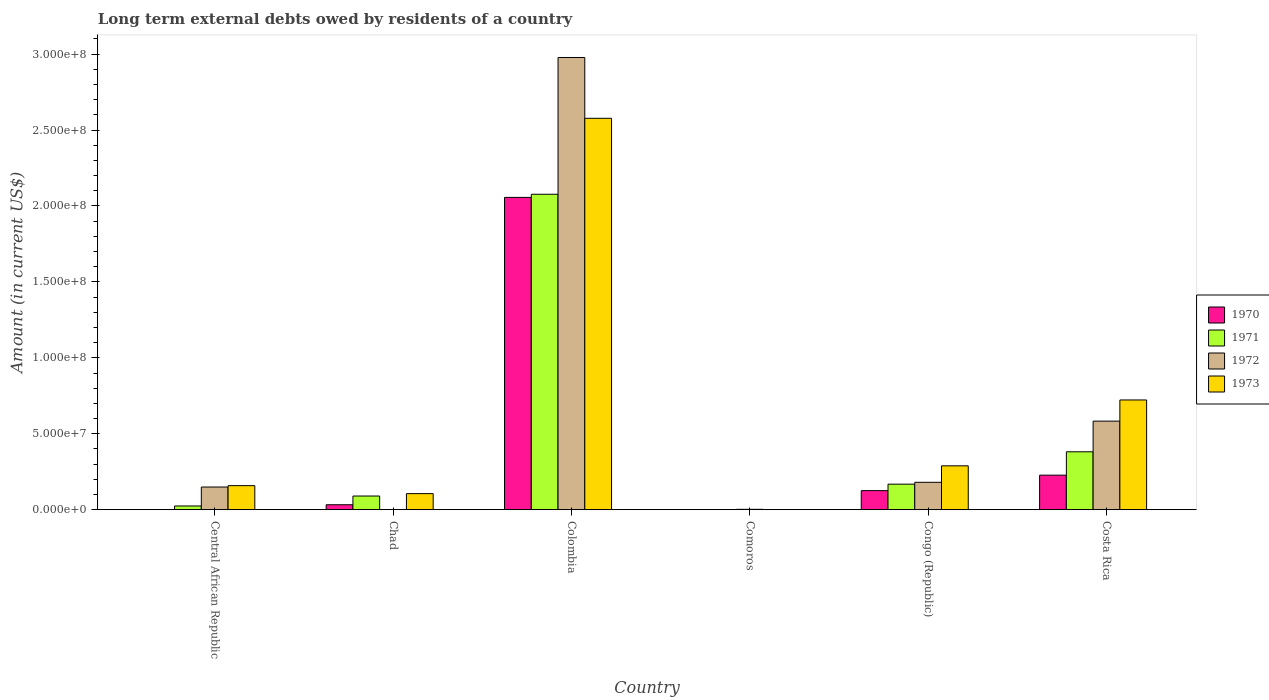Are the number of bars per tick equal to the number of legend labels?
Make the answer very short. No. What is the label of the 4th group of bars from the left?
Offer a very short reply. Comoros. In how many cases, is the number of bars for a given country not equal to the number of legend labels?
Provide a succinct answer. 3. Across all countries, what is the maximum amount of long-term external debts owed by residents in 1972?
Provide a succinct answer. 2.98e+08. Across all countries, what is the minimum amount of long-term external debts owed by residents in 1970?
Make the answer very short. 0. What is the total amount of long-term external debts owed by residents in 1971 in the graph?
Provide a short and direct response. 2.74e+08. What is the difference between the amount of long-term external debts owed by residents in 1973 in Central African Republic and that in Chad?
Your answer should be very brief. 5.26e+06. What is the difference between the amount of long-term external debts owed by residents in 1970 in Costa Rica and the amount of long-term external debts owed by residents in 1973 in Comoros?
Keep it short and to the point. 2.27e+07. What is the average amount of long-term external debts owed by residents in 1971 per country?
Provide a short and direct response. 4.57e+07. What is the difference between the amount of long-term external debts owed by residents of/in 1970 and amount of long-term external debts owed by residents of/in 1973 in Congo (Republic)?
Keep it short and to the point. -1.63e+07. What is the ratio of the amount of long-term external debts owed by residents in 1970 in Chad to that in Congo (Republic)?
Offer a very short reply. 0.26. Is the amount of long-term external debts owed by residents in 1971 in Colombia less than that in Congo (Republic)?
Make the answer very short. No. Is the difference between the amount of long-term external debts owed by residents in 1970 in Colombia and Congo (Republic) greater than the difference between the amount of long-term external debts owed by residents in 1973 in Colombia and Congo (Republic)?
Provide a short and direct response. No. What is the difference between the highest and the second highest amount of long-term external debts owed by residents in 1972?
Ensure brevity in your answer.  2.80e+08. What is the difference between the highest and the lowest amount of long-term external debts owed by residents in 1973?
Your answer should be very brief. 2.58e+08. In how many countries, is the amount of long-term external debts owed by residents in 1970 greater than the average amount of long-term external debts owed by residents in 1970 taken over all countries?
Provide a short and direct response. 1. Is it the case that in every country, the sum of the amount of long-term external debts owed by residents in 1971 and amount of long-term external debts owed by residents in 1970 is greater than the amount of long-term external debts owed by residents in 1973?
Your response must be concise. No. Are all the bars in the graph horizontal?
Provide a succinct answer. No. What is the difference between two consecutive major ticks on the Y-axis?
Offer a terse response. 5.00e+07. Does the graph contain any zero values?
Keep it short and to the point. Yes. Where does the legend appear in the graph?
Your response must be concise. Center right. How many legend labels are there?
Make the answer very short. 4. How are the legend labels stacked?
Offer a terse response. Vertical. What is the title of the graph?
Offer a very short reply. Long term external debts owed by residents of a country. Does "1995" appear as one of the legend labels in the graph?
Offer a terse response. No. What is the label or title of the X-axis?
Provide a succinct answer. Country. What is the Amount (in current US$) in 1971 in Central African Republic?
Keep it short and to the point. 2.45e+06. What is the Amount (in current US$) of 1972 in Central African Republic?
Keep it short and to the point. 1.49e+07. What is the Amount (in current US$) in 1973 in Central African Republic?
Keep it short and to the point. 1.58e+07. What is the Amount (in current US$) of 1970 in Chad?
Offer a terse response. 3.26e+06. What is the Amount (in current US$) of 1971 in Chad?
Provide a short and direct response. 9.01e+06. What is the Amount (in current US$) in 1973 in Chad?
Your answer should be compact. 1.06e+07. What is the Amount (in current US$) of 1970 in Colombia?
Your answer should be compact. 2.06e+08. What is the Amount (in current US$) of 1971 in Colombia?
Your answer should be very brief. 2.08e+08. What is the Amount (in current US$) in 1972 in Colombia?
Keep it short and to the point. 2.98e+08. What is the Amount (in current US$) of 1973 in Colombia?
Ensure brevity in your answer.  2.58e+08. What is the Amount (in current US$) of 1971 in Comoros?
Your response must be concise. 0. What is the Amount (in current US$) of 1972 in Comoros?
Your answer should be compact. 2.48e+05. What is the Amount (in current US$) of 1973 in Comoros?
Provide a short and direct response. 5.40e+04. What is the Amount (in current US$) in 1970 in Congo (Republic)?
Provide a succinct answer. 1.26e+07. What is the Amount (in current US$) in 1971 in Congo (Republic)?
Provide a short and direct response. 1.68e+07. What is the Amount (in current US$) in 1972 in Congo (Republic)?
Give a very brief answer. 1.80e+07. What is the Amount (in current US$) in 1973 in Congo (Republic)?
Your response must be concise. 2.89e+07. What is the Amount (in current US$) in 1970 in Costa Rica?
Make the answer very short. 2.27e+07. What is the Amount (in current US$) of 1971 in Costa Rica?
Ensure brevity in your answer.  3.81e+07. What is the Amount (in current US$) of 1972 in Costa Rica?
Give a very brief answer. 5.83e+07. What is the Amount (in current US$) in 1973 in Costa Rica?
Ensure brevity in your answer.  7.23e+07. Across all countries, what is the maximum Amount (in current US$) of 1970?
Your answer should be very brief. 2.06e+08. Across all countries, what is the maximum Amount (in current US$) of 1971?
Offer a very short reply. 2.08e+08. Across all countries, what is the maximum Amount (in current US$) in 1972?
Your answer should be very brief. 2.98e+08. Across all countries, what is the maximum Amount (in current US$) in 1973?
Offer a very short reply. 2.58e+08. Across all countries, what is the minimum Amount (in current US$) in 1971?
Provide a succinct answer. 0. Across all countries, what is the minimum Amount (in current US$) of 1973?
Make the answer very short. 5.40e+04. What is the total Amount (in current US$) in 1970 in the graph?
Ensure brevity in your answer.  2.44e+08. What is the total Amount (in current US$) in 1971 in the graph?
Your response must be concise. 2.74e+08. What is the total Amount (in current US$) of 1972 in the graph?
Ensure brevity in your answer.  3.89e+08. What is the total Amount (in current US$) of 1973 in the graph?
Keep it short and to the point. 3.85e+08. What is the difference between the Amount (in current US$) of 1971 in Central African Republic and that in Chad?
Make the answer very short. -6.56e+06. What is the difference between the Amount (in current US$) of 1973 in Central African Republic and that in Chad?
Keep it short and to the point. 5.26e+06. What is the difference between the Amount (in current US$) in 1971 in Central African Republic and that in Colombia?
Make the answer very short. -2.05e+08. What is the difference between the Amount (in current US$) of 1972 in Central African Republic and that in Colombia?
Offer a terse response. -2.83e+08. What is the difference between the Amount (in current US$) of 1973 in Central African Republic and that in Colombia?
Provide a short and direct response. -2.42e+08. What is the difference between the Amount (in current US$) of 1972 in Central African Republic and that in Comoros?
Provide a succinct answer. 1.47e+07. What is the difference between the Amount (in current US$) in 1973 in Central African Republic and that in Comoros?
Give a very brief answer. 1.58e+07. What is the difference between the Amount (in current US$) in 1971 in Central African Republic and that in Congo (Republic)?
Make the answer very short. -1.44e+07. What is the difference between the Amount (in current US$) in 1972 in Central African Republic and that in Congo (Republic)?
Offer a very short reply. -3.10e+06. What is the difference between the Amount (in current US$) in 1973 in Central African Republic and that in Congo (Republic)?
Provide a succinct answer. -1.30e+07. What is the difference between the Amount (in current US$) of 1971 in Central African Republic and that in Costa Rica?
Provide a short and direct response. -3.57e+07. What is the difference between the Amount (in current US$) of 1972 in Central African Republic and that in Costa Rica?
Ensure brevity in your answer.  -4.34e+07. What is the difference between the Amount (in current US$) in 1973 in Central African Republic and that in Costa Rica?
Your response must be concise. -5.64e+07. What is the difference between the Amount (in current US$) in 1970 in Chad and that in Colombia?
Make the answer very short. -2.02e+08. What is the difference between the Amount (in current US$) in 1971 in Chad and that in Colombia?
Provide a succinct answer. -1.99e+08. What is the difference between the Amount (in current US$) in 1973 in Chad and that in Colombia?
Provide a short and direct response. -2.47e+08. What is the difference between the Amount (in current US$) of 1973 in Chad and that in Comoros?
Ensure brevity in your answer.  1.05e+07. What is the difference between the Amount (in current US$) in 1970 in Chad and that in Congo (Republic)?
Keep it short and to the point. -9.29e+06. What is the difference between the Amount (in current US$) of 1971 in Chad and that in Congo (Republic)?
Provide a succinct answer. -7.80e+06. What is the difference between the Amount (in current US$) in 1973 in Chad and that in Congo (Republic)?
Give a very brief answer. -1.83e+07. What is the difference between the Amount (in current US$) in 1970 in Chad and that in Costa Rica?
Provide a short and direct response. -1.95e+07. What is the difference between the Amount (in current US$) in 1971 in Chad and that in Costa Rica?
Your answer should be very brief. -2.91e+07. What is the difference between the Amount (in current US$) of 1973 in Chad and that in Costa Rica?
Provide a succinct answer. -6.17e+07. What is the difference between the Amount (in current US$) of 1972 in Colombia and that in Comoros?
Ensure brevity in your answer.  2.98e+08. What is the difference between the Amount (in current US$) in 1973 in Colombia and that in Comoros?
Your answer should be very brief. 2.58e+08. What is the difference between the Amount (in current US$) of 1970 in Colombia and that in Congo (Republic)?
Make the answer very short. 1.93e+08. What is the difference between the Amount (in current US$) in 1971 in Colombia and that in Congo (Republic)?
Keep it short and to the point. 1.91e+08. What is the difference between the Amount (in current US$) in 1972 in Colombia and that in Congo (Republic)?
Your answer should be compact. 2.80e+08. What is the difference between the Amount (in current US$) of 1973 in Colombia and that in Congo (Republic)?
Offer a terse response. 2.29e+08. What is the difference between the Amount (in current US$) of 1970 in Colombia and that in Costa Rica?
Provide a succinct answer. 1.83e+08. What is the difference between the Amount (in current US$) of 1971 in Colombia and that in Costa Rica?
Provide a succinct answer. 1.70e+08. What is the difference between the Amount (in current US$) of 1972 in Colombia and that in Costa Rica?
Provide a short and direct response. 2.39e+08. What is the difference between the Amount (in current US$) in 1973 in Colombia and that in Costa Rica?
Your answer should be compact. 1.85e+08. What is the difference between the Amount (in current US$) in 1972 in Comoros and that in Congo (Republic)?
Offer a very short reply. -1.78e+07. What is the difference between the Amount (in current US$) of 1973 in Comoros and that in Congo (Republic)?
Offer a terse response. -2.88e+07. What is the difference between the Amount (in current US$) in 1972 in Comoros and that in Costa Rica?
Provide a short and direct response. -5.81e+07. What is the difference between the Amount (in current US$) in 1973 in Comoros and that in Costa Rica?
Make the answer very short. -7.22e+07. What is the difference between the Amount (in current US$) of 1970 in Congo (Republic) and that in Costa Rica?
Give a very brief answer. -1.02e+07. What is the difference between the Amount (in current US$) in 1971 in Congo (Republic) and that in Costa Rica?
Ensure brevity in your answer.  -2.13e+07. What is the difference between the Amount (in current US$) in 1972 in Congo (Republic) and that in Costa Rica?
Your answer should be very brief. -4.03e+07. What is the difference between the Amount (in current US$) of 1973 in Congo (Republic) and that in Costa Rica?
Your response must be concise. -4.34e+07. What is the difference between the Amount (in current US$) in 1971 in Central African Republic and the Amount (in current US$) in 1973 in Chad?
Your answer should be compact. -8.13e+06. What is the difference between the Amount (in current US$) of 1972 in Central African Republic and the Amount (in current US$) of 1973 in Chad?
Offer a very short reply. 4.35e+06. What is the difference between the Amount (in current US$) of 1971 in Central African Republic and the Amount (in current US$) of 1972 in Colombia?
Give a very brief answer. -2.95e+08. What is the difference between the Amount (in current US$) of 1971 in Central African Republic and the Amount (in current US$) of 1973 in Colombia?
Give a very brief answer. -2.55e+08. What is the difference between the Amount (in current US$) in 1972 in Central African Republic and the Amount (in current US$) in 1973 in Colombia?
Give a very brief answer. -2.43e+08. What is the difference between the Amount (in current US$) of 1971 in Central African Republic and the Amount (in current US$) of 1972 in Comoros?
Make the answer very short. 2.20e+06. What is the difference between the Amount (in current US$) of 1971 in Central African Republic and the Amount (in current US$) of 1973 in Comoros?
Provide a short and direct response. 2.40e+06. What is the difference between the Amount (in current US$) in 1972 in Central African Republic and the Amount (in current US$) in 1973 in Comoros?
Ensure brevity in your answer.  1.49e+07. What is the difference between the Amount (in current US$) in 1971 in Central African Republic and the Amount (in current US$) in 1972 in Congo (Republic)?
Make the answer very short. -1.56e+07. What is the difference between the Amount (in current US$) of 1971 in Central African Republic and the Amount (in current US$) of 1973 in Congo (Republic)?
Provide a short and direct response. -2.64e+07. What is the difference between the Amount (in current US$) of 1972 in Central African Republic and the Amount (in current US$) of 1973 in Congo (Republic)?
Provide a short and direct response. -1.39e+07. What is the difference between the Amount (in current US$) of 1971 in Central African Republic and the Amount (in current US$) of 1972 in Costa Rica?
Keep it short and to the point. -5.59e+07. What is the difference between the Amount (in current US$) in 1971 in Central African Republic and the Amount (in current US$) in 1973 in Costa Rica?
Your response must be concise. -6.98e+07. What is the difference between the Amount (in current US$) in 1972 in Central African Republic and the Amount (in current US$) in 1973 in Costa Rica?
Make the answer very short. -5.73e+07. What is the difference between the Amount (in current US$) in 1970 in Chad and the Amount (in current US$) in 1971 in Colombia?
Your response must be concise. -2.04e+08. What is the difference between the Amount (in current US$) in 1970 in Chad and the Amount (in current US$) in 1972 in Colombia?
Your answer should be very brief. -2.94e+08. What is the difference between the Amount (in current US$) in 1970 in Chad and the Amount (in current US$) in 1973 in Colombia?
Your answer should be compact. -2.54e+08. What is the difference between the Amount (in current US$) of 1971 in Chad and the Amount (in current US$) of 1972 in Colombia?
Make the answer very short. -2.89e+08. What is the difference between the Amount (in current US$) in 1971 in Chad and the Amount (in current US$) in 1973 in Colombia?
Your answer should be compact. -2.49e+08. What is the difference between the Amount (in current US$) in 1970 in Chad and the Amount (in current US$) in 1972 in Comoros?
Offer a terse response. 3.02e+06. What is the difference between the Amount (in current US$) of 1970 in Chad and the Amount (in current US$) of 1973 in Comoros?
Make the answer very short. 3.21e+06. What is the difference between the Amount (in current US$) in 1971 in Chad and the Amount (in current US$) in 1972 in Comoros?
Keep it short and to the point. 8.76e+06. What is the difference between the Amount (in current US$) in 1971 in Chad and the Amount (in current US$) in 1973 in Comoros?
Provide a succinct answer. 8.95e+06. What is the difference between the Amount (in current US$) in 1970 in Chad and the Amount (in current US$) in 1971 in Congo (Republic)?
Your answer should be compact. -1.35e+07. What is the difference between the Amount (in current US$) of 1970 in Chad and the Amount (in current US$) of 1972 in Congo (Republic)?
Give a very brief answer. -1.48e+07. What is the difference between the Amount (in current US$) of 1970 in Chad and the Amount (in current US$) of 1973 in Congo (Republic)?
Offer a very short reply. -2.56e+07. What is the difference between the Amount (in current US$) in 1971 in Chad and the Amount (in current US$) in 1972 in Congo (Republic)?
Provide a short and direct response. -9.03e+06. What is the difference between the Amount (in current US$) in 1971 in Chad and the Amount (in current US$) in 1973 in Congo (Republic)?
Ensure brevity in your answer.  -1.99e+07. What is the difference between the Amount (in current US$) of 1970 in Chad and the Amount (in current US$) of 1971 in Costa Rica?
Ensure brevity in your answer.  -3.49e+07. What is the difference between the Amount (in current US$) in 1970 in Chad and the Amount (in current US$) in 1972 in Costa Rica?
Your response must be concise. -5.50e+07. What is the difference between the Amount (in current US$) of 1970 in Chad and the Amount (in current US$) of 1973 in Costa Rica?
Offer a very short reply. -6.90e+07. What is the difference between the Amount (in current US$) of 1971 in Chad and the Amount (in current US$) of 1972 in Costa Rica?
Ensure brevity in your answer.  -4.93e+07. What is the difference between the Amount (in current US$) in 1971 in Chad and the Amount (in current US$) in 1973 in Costa Rica?
Your answer should be compact. -6.32e+07. What is the difference between the Amount (in current US$) in 1970 in Colombia and the Amount (in current US$) in 1972 in Comoros?
Provide a succinct answer. 2.05e+08. What is the difference between the Amount (in current US$) of 1970 in Colombia and the Amount (in current US$) of 1973 in Comoros?
Offer a very short reply. 2.06e+08. What is the difference between the Amount (in current US$) in 1971 in Colombia and the Amount (in current US$) in 1972 in Comoros?
Your answer should be very brief. 2.07e+08. What is the difference between the Amount (in current US$) in 1971 in Colombia and the Amount (in current US$) in 1973 in Comoros?
Provide a succinct answer. 2.08e+08. What is the difference between the Amount (in current US$) in 1972 in Colombia and the Amount (in current US$) in 1973 in Comoros?
Provide a short and direct response. 2.98e+08. What is the difference between the Amount (in current US$) of 1970 in Colombia and the Amount (in current US$) of 1971 in Congo (Republic)?
Your response must be concise. 1.89e+08. What is the difference between the Amount (in current US$) of 1970 in Colombia and the Amount (in current US$) of 1972 in Congo (Republic)?
Offer a very short reply. 1.88e+08. What is the difference between the Amount (in current US$) of 1970 in Colombia and the Amount (in current US$) of 1973 in Congo (Republic)?
Your answer should be very brief. 1.77e+08. What is the difference between the Amount (in current US$) of 1971 in Colombia and the Amount (in current US$) of 1972 in Congo (Republic)?
Your answer should be very brief. 1.90e+08. What is the difference between the Amount (in current US$) in 1971 in Colombia and the Amount (in current US$) in 1973 in Congo (Republic)?
Ensure brevity in your answer.  1.79e+08. What is the difference between the Amount (in current US$) in 1972 in Colombia and the Amount (in current US$) in 1973 in Congo (Republic)?
Offer a very short reply. 2.69e+08. What is the difference between the Amount (in current US$) of 1970 in Colombia and the Amount (in current US$) of 1971 in Costa Rica?
Provide a short and direct response. 1.68e+08. What is the difference between the Amount (in current US$) of 1970 in Colombia and the Amount (in current US$) of 1972 in Costa Rica?
Offer a very short reply. 1.47e+08. What is the difference between the Amount (in current US$) in 1970 in Colombia and the Amount (in current US$) in 1973 in Costa Rica?
Provide a succinct answer. 1.33e+08. What is the difference between the Amount (in current US$) in 1971 in Colombia and the Amount (in current US$) in 1972 in Costa Rica?
Your answer should be very brief. 1.49e+08. What is the difference between the Amount (in current US$) in 1971 in Colombia and the Amount (in current US$) in 1973 in Costa Rica?
Keep it short and to the point. 1.35e+08. What is the difference between the Amount (in current US$) in 1972 in Colombia and the Amount (in current US$) in 1973 in Costa Rica?
Make the answer very short. 2.26e+08. What is the difference between the Amount (in current US$) in 1972 in Comoros and the Amount (in current US$) in 1973 in Congo (Republic)?
Give a very brief answer. -2.86e+07. What is the difference between the Amount (in current US$) of 1972 in Comoros and the Amount (in current US$) of 1973 in Costa Rica?
Offer a terse response. -7.20e+07. What is the difference between the Amount (in current US$) in 1970 in Congo (Republic) and the Amount (in current US$) in 1971 in Costa Rica?
Your answer should be very brief. -2.56e+07. What is the difference between the Amount (in current US$) of 1970 in Congo (Republic) and the Amount (in current US$) of 1972 in Costa Rica?
Your answer should be very brief. -4.58e+07. What is the difference between the Amount (in current US$) of 1970 in Congo (Republic) and the Amount (in current US$) of 1973 in Costa Rica?
Keep it short and to the point. -5.97e+07. What is the difference between the Amount (in current US$) in 1971 in Congo (Republic) and the Amount (in current US$) in 1972 in Costa Rica?
Keep it short and to the point. -4.15e+07. What is the difference between the Amount (in current US$) in 1971 in Congo (Republic) and the Amount (in current US$) in 1973 in Costa Rica?
Give a very brief answer. -5.54e+07. What is the difference between the Amount (in current US$) of 1972 in Congo (Republic) and the Amount (in current US$) of 1973 in Costa Rica?
Keep it short and to the point. -5.42e+07. What is the average Amount (in current US$) in 1970 per country?
Ensure brevity in your answer.  4.07e+07. What is the average Amount (in current US$) in 1971 per country?
Offer a very short reply. 4.57e+07. What is the average Amount (in current US$) of 1972 per country?
Offer a very short reply. 6.49e+07. What is the average Amount (in current US$) of 1973 per country?
Keep it short and to the point. 6.42e+07. What is the difference between the Amount (in current US$) of 1971 and Amount (in current US$) of 1972 in Central African Republic?
Your response must be concise. -1.25e+07. What is the difference between the Amount (in current US$) in 1971 and Amount (in current US$) in 1973 in Central African Republic?
Keep it short and to the point. -1.34e+07. What is the difference between the Amount (in current US$) in 1972 and Amount (in current US$) in 1973 in Central African Republic?
Make the answer very short. -9.04e+05. What is the difference between the Amount (in current US$) in 1970 and Amount (in current US$) in 1971 in Chad?
Provide a short and direct response. -5.74e+06. What is the difference between the Amount (in current US$) of 1970 and Amount (in current US$) of 1973 in Chad?
Keep it short and to the point. -7.32e+06. What is the difference between the Amount (in current US$) of 1971 and Amount (in current US$) of 1973 in Chad?
Provide a succinct answer. -1.57e+06. What is the difference between the Amount (in current US$) of 1970 and Amount (in current US$) of 1971 in Colombia?
Your answer should be very brief. -2.06e+06. What is the difference between the Amount (in current US$) of 1970 and Amount (in current US$) of 1972 in Colombia?
Your answer should be very brief. -9.21e+07. What is the difference between the Amount (in current US$) in 1970 and Amount (in current US$) in 1973 in Colombia?
Provide a succinct answer. -5.21e+07. What is the difference between the Amount (in current US$) in 1971 and Amount (in current US$) in 1972 in Colombia?
Make the answer very short. -9.01e+07. What is the difference between the Amount (in current US$) in 1971 and Amount (in current US$) in 1973 in Colombia?
Keep it short and to the point. -5.00e+07. What is the difference between the Amount (in current US$) of 1972 and Amount (in current US$) of 1973 in Colombia?
Provide a succinct answer. 4.00e+07. What is the difference between the Amount (in current US$) of 1972 and Amount (in current US$) of 1973 in Comoros?
Your response must be concise. 1.94e+05. What is the difference between the Amount (in current US$) of 1970 and Amount (in current US$) of 1971 in Congo (Republic)?
Your answer should be very brief. -4.26e+06. What is the difference between the Amount (in current US$) of 1970 and Amount (in current US$) of 1972 in Congo (Republic)?
Your answer should be very brief. -5.48e+06. What is the difference between the Amount (in current US$) of 1970 and Amount (in current US$) of 1973 in Congo (Republic)?
Offer a very short reply. -1.63e+07. What is the difference between the Amount (in current US$) in 1971 and Amount (in current US$) in 1972 in Congo (Republic)?
Your answer should be compact. -1.23e+06. What is the difference between the Amount (in current US$) of 1971 and Amount (in current US$) of 1973 in Congo (Republic)?
Offer a very short reply. -1.21e+07. What is the difference between the Amount (in current US$) of 1972 and Amount (in current US$) of 1973 in Congo (Republic)?
Offer a terse response. -1.08e+07. What is the difference between the Amount (in current US$) in 1970 and Amount (in current US$) in 1971 in Costa Rica?
Provide a succinct answer. -1.54e+07. What is the difference between the Amount (in current US$) of 1970 and Amount (in current US$) of 1972 in Costa Rica?
Keep it short and to the point. -3.56e+07. What is the difference between the Amount (in current US$) of 1970 and Amount (in current US$) of 1973 in Costa Rica?
Provide a short and direct response. -4.95e+07. What is the difference between the Amount (in current US$) in 1971 and Amount (in current US$) in 1972 in Costa Rica?
Provide a succinct answer. -2.02e+07. What is the difference between the Amount (in current US$) in 1971 and Amount (in current US$) in 1973 in Costa Rica?
Provide a short and direct response. -3.41e+07. What is the difference between the Amount (in current US$) in 1972 and Amount (in current US$) in 1973 in Costa Rica?
Your answer should be very brief. -1.39e+07. What is the ratio of the Amount (in current US$) of 1971 in Central African Republic to that in Chad?
Provide a succinct answer. 0.27. What is the ratio of the Amount (in current US$) in 1973 in Central African Republic to that in Chad?
Provide a short and direct response. 1.5. What is the ratio of the Amount (in current US$) of 1971 in Central African Republic to that in Colombia?
Provide a short and direct response. 0.01. What is the ratio of the Amount (in current US$) of 1972 in Central African Republic to that in Colombia?
Your answer should be very brief. 0.05. What is the ratio of the Amount (in current US$) in 1973 in Central African Republic to that in Colombia?
Offer a very short reply. 0.06. What is the ratio of the Amount (in current US$) of 1972 in Central African Republic to that in Comoros?
Give a very brief answer. 60.21. What is the ratio of the Amount (in current US$) of 1973 in Central African Republic to that in Comoros?
Ensure brevity in your answer.  293.26. What is the ratio of the Amount (in current US$) of 1971 in Central African Republic to that in Congo (Republic)?
Your answer should be very brief. 0.15. What is the ratio of the Amount (in current US$) of 1972 in Central African Republic to that in Congo (Republic)?
Your answer should be very brief. 0.83. What is the ratio of the Amount (in current US$) in 1973 in Central African Republic to that in Congo (Republic)?
Your answer should be compact. 0.55. What is the ratio of the Amount (in current US$) of 1971 in Central African Republic to that in Costa Rica?
Keep it short and to the point. 0.06. What is the ratio of the Amount (in current US$) in 1972 in Central African Republic to that in Costa Rica?
Your answer should be compact. 0.26. What is the ratio of the Amount (in current US$) in 1973 in Central African Republic to that in Costa Rica?
Make the answer very short. 0.22. What is the ratio of the Amount (in current US$) of 1970 in Chad to that in Colombia?
Ensure brevity in your answer.  0.02. What is the ratio of the Amount (in current US$) of 1971 in Chad to that in Colombia?
Give a very brief answer. 0.04. What is the ratio of the Amount (in current US$) of 1973 in Chad to that in Colombia?
Offer a terse response. 0.04. What is the ratio of the Amount (in current US$) in 1973 in Chad to that in Comoros?
Offer a terse response. 195.94. What is the ratio of the Amount (in current US$) in 1970 in Chad to that in Congo (Republic)?
Your answer should be very brief. 0.26. What is the ratio of the Amount (in current US$) of 1971 in Chad to that in Congo (Republic)?
Make the answer very short. 0.54. What is the ratio of the Amount (in current US$) of 1973 in Chad to that in Congo (Republic)?
Make the answer very short. 0.37. What is the ratio of the Amount (in current US$) in 1970 in Chad to that in Costa Rica?
Make the answer very short. 0.14. What is the ratio of the Amount (in current US$) of 1971 in Chad to that in Costa Rica?
Provide a succinct answer. 0.24. What is the ratio of the Amount (in current US$) in 1973 in Chad to that in Costa Rica?
Ensure brevity in your answer.  0.15. What is the ratio of the Amount (in current US$) of 1972 in Colombia to that in Comoros?
Your answer should be compact. 1200.66. What is the ratio of the Amount (in current US$) in 1973 in Colombia to that in Comoros?
Keep it short and to the point. 4772.54. What is the ratio of the Amount (in current US$) in 1970 in Colombia to that in Congo (Republic)?
Offer a terse response. 16.39. What is the ratio of the Amount (in current US$) in 1971 in Colombia to that in Congo (Republic)?
Your answer should be compact. 12.36. What is the ratio of the Amount (in current US$) of 1972 in Colombia to that in Congo (Republic)?
Provide a short and direct response. 16.51. What is the ratio of the Amount (in current US$) in 1973 in Colombia to that in Congo (Republic)?
Give a very brief answer. 8.92. What is the ratio of the Amount (in current US$) in 1970 in Colombia to that in Costa Rica?
Your response must be concise. 9.05. What is the ratio of the Amount (in current US$) in 1971 in Colombia to that in Costa Rica?
Your answer should be compact. 5.45. What is the ratio of the Amount (in current US$) in 1972 in Colombia to that in Costa Rica?
Your response must be concise. 5.11. What is the ratio of the Amount (in current US$) in 1973 in Colombia to that in Costa Rica?
Make the answer very short. 3.57. What is the ratio of the Amount (in current US$) in 1972 in Comoros to that in Congo (Republic)?
Make the answer very short. 0.01. What is the ratio of the Amount (in current US$) of 1973 in Comoros to that in Congo (Republic)?
Offer a very short reply. 0. What is the ratio of the Amount (in current US$) in 1972 in Comoros to that in Costa Rica?
Ensure brevity in your answer.  0. What is the ratio of the Amount (in current US$) of 1973 in Comoros to that in Costa Rica?
Your answer should be compact. 0. What is the ratio of the Amount (in current US$) in 1970 in Congo (Republic) to that in Costa Rica?
Your answer should be very brief. 0.55. What is the ratio of the Amount (in current US$) of 1971 in Congo (Republic) to that in Costa Rica?
Give a very brief answer. 0.44. What is the ratio of the Amount (in current US$) in 1972 in Congo (Republic) to that in Costa Rica?
Ensure brevity in your answer.  0.31. What is the ratio of the Amount (in current US$) in 1973 in Congo (Republic) to that in Costa Rica?
Your answer should be very brief. 0.4. What is the difference between the highest and the second highest Amount (in current US$) of 1970?
Offer a very short reply. 1.83e+08. What is the difference between the highest and the second highest Amount (in current US$) in 1971?
Ensure brevity in your answer.  1.70e+08. What is the difference between the highest and the second highest Amount (in current US$) of 1972?
Make the answer very short. 2.39e+08. What is the difference between the highest and the second highest Amount (in current US$) of 1973?
Give a very brief answer. 1.85e+08. What is the difference between the highest and the lowest Amount (in current US$) of 1970?
Offer a very short reply. 2.06e+08. What is the difference between the highest and the lowest Amount (in current US$) of 1971?
Provide a short and direct response. 2.08e+08. What is the difference between the highest and the lowest Amount (in current US$) in 1972?
Give a very brief answer. 2.98e+08. What is the difference between the highest and the lowest Amount (in current US$) of 1973?
Ensure brevity in your answer.  2.58e+08. 